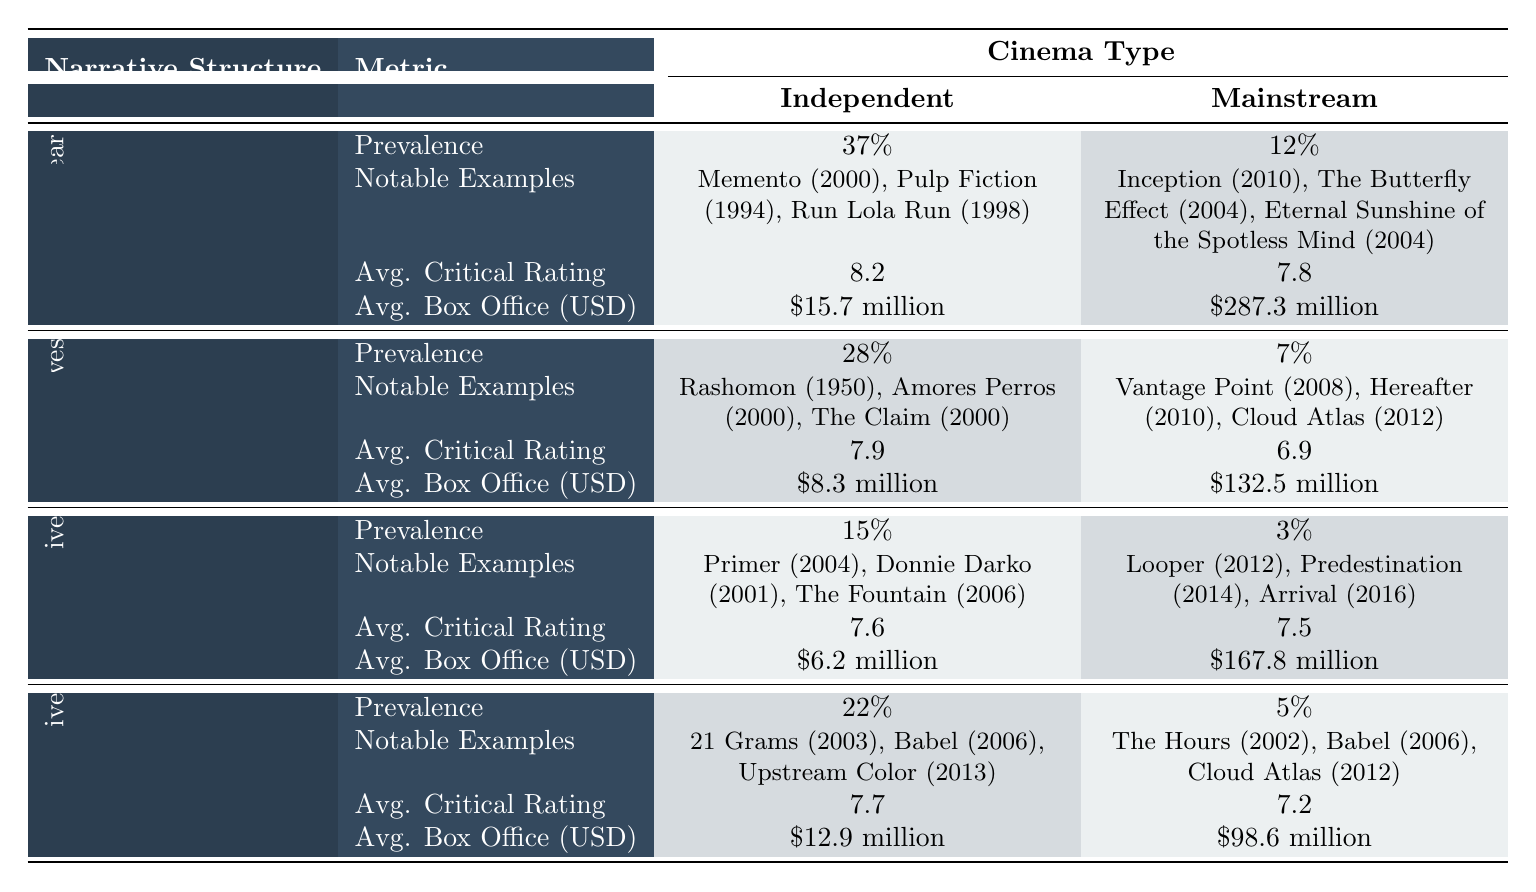What is the average critical rating for non-linear narrative structures in independent cinema? The average critical rating listed for non-linear narrative structures in independent cinema is 8.2.
Answer: 8.2 Which type of narrative structure has the highest prevalence in independent cinema? According to the table, non-linear narrative structures have the highest prevalence in independent cinema at 37%.
Answer: Non-linear What is the average box office for multiple perspectives narrative structures in mainstream cinema? The average box office for multiple perspectives narrative structures in mainstream cinema is $132.5 million.
Answer: $132.5 million Are there any notable examples listed for circular narratives in mainstream cinema? Yes, notable examples for circular narratives in mainstream cinema include Looper (2012), Predestination (2014), and Arrival (2016).
Answer: Yes Which narrative structure in independent cinema has a lower average critical rating than circular narratives in mainstream cinema? The average critical rating for fragmented narratives in independent cinema is 7.7, which is lower than 7.5 for circular narratives in mainstream cinema.
Answer: Fragmented Narrative What is the difference in prevalence rates of fragmented narratives between independent and mainstream cinema? The prevalence of fragmented narratives in independent cinema is 22%, while in mainstream cinema it is 5%. The difference is 22% - 5% = 17%.
Answer: 17% Between non-linear and fragmented narratives, which one has a higher average box office in independent cinema? The average box office for non-linear narratives is $15.7 million, and for fragmented narratives, it is $12.9 million. Since $15.7 million is greater than $12.9 million, non-linear narratives have a higher average box office.
Answer: Non-linear Narratives What is the average critical rating for all narrative structures in independent cinema? The average critical ratings for each structure are: non-linear (8.2), multiple perspectives (7.9), circular (7.6), and fragmented (7.7). The total is 8.2 + 7.9 + 7.6 + 7.7 = 31.4, divided by 4 gives an average of 31.4/4 = 7.85.
Answer: 7.85 Which cinema type has a higher average box office for circular narratives? The average box office for circular narratives in mainstream cinema is $167.8 million, while in independent cinema it's $6.2 million. Since $167.8 million is greater, mainstream cinema has a higher average box office for circular narratives.
Answer: Mainstream Cinema Is it true that the average critical rating for multiple perspectives narratives in mainstream cinema is above 8? The average critical rating for multiple perspectives narratives in mainstream cinema is 6.9, which is below 8. Hence, it is not true.
Answer: No 